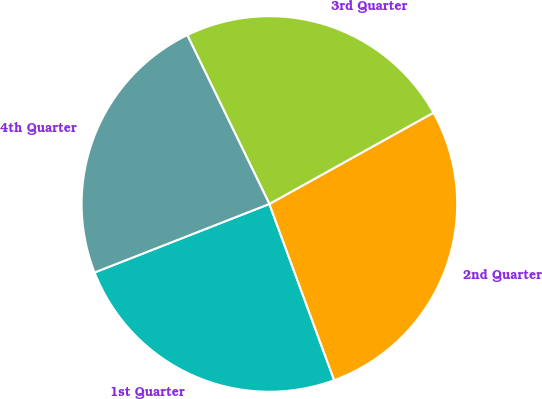Convert chart. <chart><loc_0><loc_0><loc_500><loc_500><pie_chart><fcel>1st Quarter<fcel>2nd Quarter<fcel>3rd Quarter<fcel>4th Quarter<nl><fcel>24.66%<fcel>27.47%<fcel>24.12%<fcel>23.74%<nl></chart> 